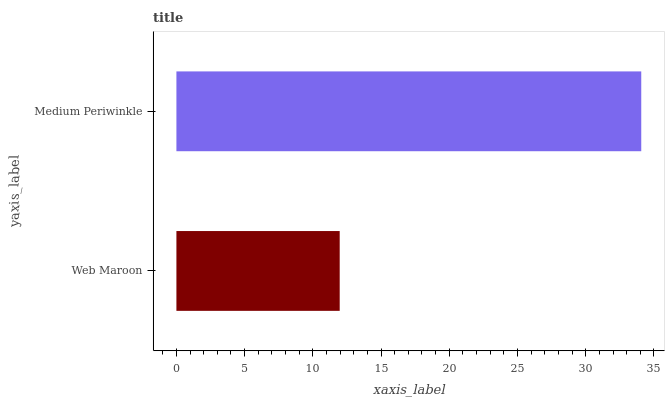Is Web Maroon the minimum?
Answer yes or no. Yes. Is Medium Periwinkle the maximum?
Answer yes or no. Yes. Is Medium Periwinkle the minimum?
Answer yes or no. No. Is Medium Periwinkle greater than Web Maroon?
Answer yes or no. Yes. Is Web Maroon less than Medium Periwinkle?
Answer yes or no. Yes. Is Web Maroon greater than Medium Periwinkle?
Answer yes or no. No. Is Medium Periwinkle less than Web Maroon?
Answer yes or no. No. Is Medium Periwinkle the high median?
Answer yes or no. Yes. Is Web Maroon the low median?
Answer yes or no. Yes. Is Web Maroon the high median?
Answer yes or no. No. Is Medium Periwinkle the low median?
Answer yes or no. No. 